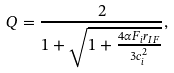Convert formula to latex. <formula><loc_0><loc_0><loc_500><loc_500>Q = \frac { 2 } { 1 + \sqrt { 1 + \frac { 4 \alpha F _ { i } r _ { I F } } { 3 c _ { i } ^ { 2 } } } } ,</formula> 